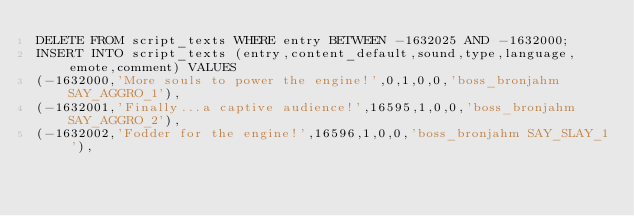Convert code to text. <code><loc_0><loc_0><loc_500><loc_500><_SQL_>DELETE FROM script_texts WHERE entry BETWEEN -1632025 AND -1632000;
INSERT INTO script_texts (entry,content_default,sound,type,language,emote,comment) VALUES
(-1632000,'More souls to power the engine!',0,1,0,0,'boss_bronjahm SAY_AGGRO_1'),
(-1632001,'Finally...a captive audience!',16595,1,0,0,'boss_bronjahm SAY_AGGRO_2'),
(-1632002,'Fodder for the engine!',16596,1,0,0,'boss_bronjahm SAY_SLAY_1'),</code> 